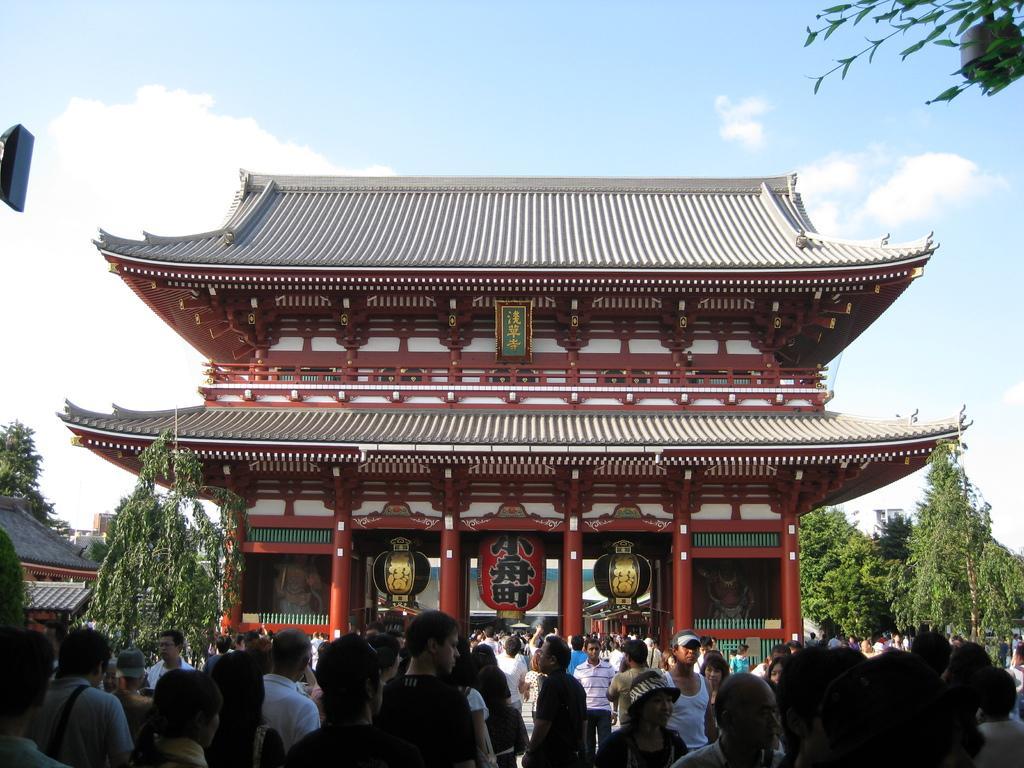Please provide a concise description of this image. At the bottom there are many people are standing, in the middle it is a house, there are trees on either side of this house. At the top it is the sky. 